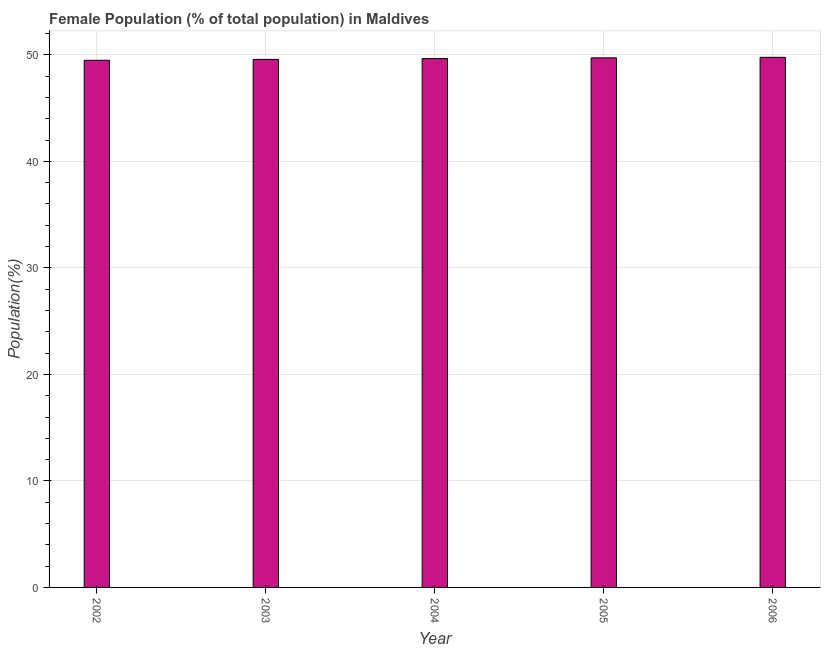Does the graph contain any zero values?
Offer a very short reply. No. What is the title of the graph?
Offer a terse response. Female Population (% of total population) in Maldives. What is the label or title of the X-axis?
Your response must be concise. Year. What is the label or title of the Y-axis?
Keep it short and to the point. Population(%). What is the female population in 2006?
Offer a terse response. 49.77. Across all years, what is the maximum female population?
Keep it short and to the point. 49.77. Across all years, what is the minimum female population?
Ensure brevity in your answer.  49.49. What is the sum of the female population?
Your response must be concise. 248.21. What is the difference between the female population in 2002 and 2004?
Keep it short and to the point. -0.16. What is the average female population per year?
Your answer should be compact. 49.64. What is the median female population?
Offer a terse response. 49.66. Do a majority of the years between 2002 and 2005 (inclusive) have female population greater than 38 %?
Offer a terse response. Yes. What is the difference between the highest and the second highest female population?
Ensure brevity in your answer.  0.05. Is the sum of the female population in 2002 and 2005 greater than the maximum female population across all years?
Make the answer very short. Yes. What is the difference between the highest and the lowest female population?
Offer a terse response. 0.28. How many bars are there?
Offer a terse response. 5. How many years are there in the graph?
Offer a terse response. 5. What is the Population(%) in 2002?
Provide a short and direct response. 49.49. What is the Population(%) in 2003?
Give a very brief answer. 49.57. What is the Population(%) of 2004?
Your answer should be very brief. 49.66. What is the Population(%) of 2005?
Ensure brevity in your answer.  49.72. What is the Population(%) of 2006?
Keep it short and to the point. 49.77. What is the difference between the Population(%) in 2002 and 2003?
Your answer should be very brief. -0.08. What is the difference between the Population(%) in 2002 and 2004?
Your response must be concise. -0.16. What is the difference between the Population(%) in 2002 and 2005?
Provide a succinct answer. -0.23. What is the difference between the Population(%) in 2002 and 2006?
Ensure brevity in your answer.  -0.28. What is the difference between the Population(%) in 2003 and 2004?
Keep it short and to the point. -0.08. What is the difference between the Population(%) in 2003 and 2005?
Offer a terse response. -0.15. What is the difference between the Population(%) in 2003 and 2006?
Your response must be concise. -0.19. What is the difference between the Population(%) in 2004 and 2005?
Offer a terse response. -0.07. What is the difference between the Population(%) in 2004 and 2006?
Keep it short and to the point. -0.11. What is the difference between the Population(%) in 2005 and 2006?
Keep it short and to the point. -0.05. What is the ratio of the Population(%) in 2004 to that in 2005?
Your answer should be compact. 1. What is the ratio of the Population(%) in 2005 to that in 2006?
Make the answer very short. 1. 